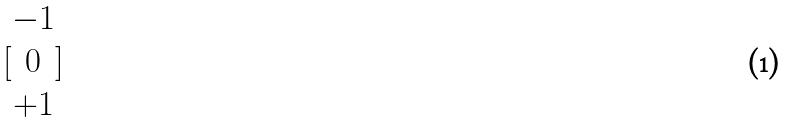Convert formula to latex. <formula><loc_0><loc_0><loc_500><loc_500>[ \begin{matrix} - 1 \\ 0 \\ + 1 \end{matrix} ]</formula> 